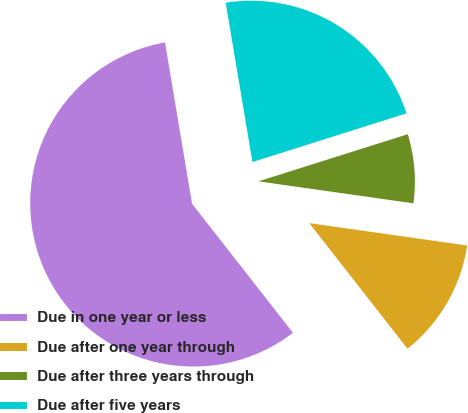Convert chart. <chart><loc_0><loc_0><loc_500><loc_500><pie_chart><fcel>Due in one year or less<fcel>Due after one year through<fcel>Due after three years through<fcel>Due after five years<nl><fcel>57.92%<fcel>12.19%<fcel>7.11%<fcel>22.78%<nl></chart> 